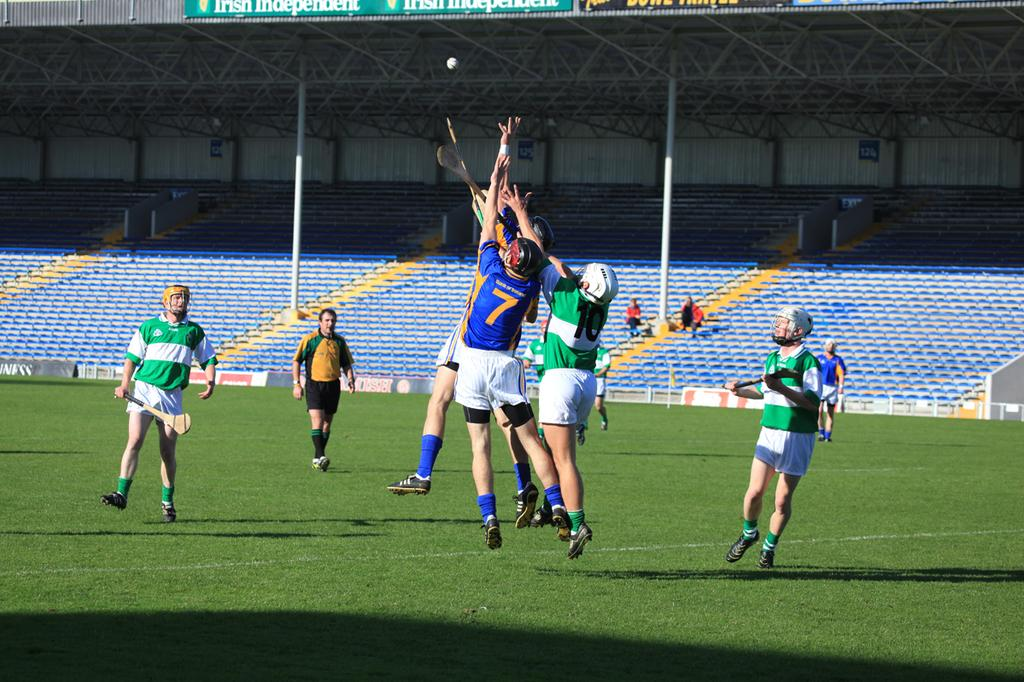Who is present in the image? There are people in the image. What are the people doing in the image? The people are playing a game. Where is the game being played? The game is being played on the ground. What can be seen in the background of the image? There is a stadium visible in the background of the image. What type of caption is written on the jellyfish in the image? There is no jellyfish present in the image, and therefore no caption can be found on it. 